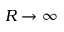Convert formula to latex. <formula><loc_0><loc_0><loc_500><loc_500>R \to \infty</formula> 